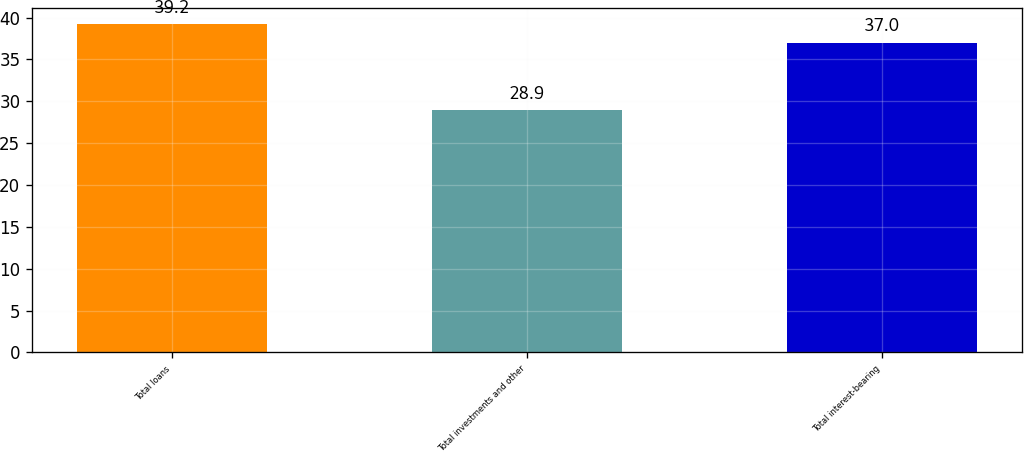Convert chart to OTSL. <chart><loc_0><loc_0><loc_500><loc_500><bar_chart><fcel>Total loans<fcel>Total investments and other<fcel>Total interest-bearing<nl><fcel>39.2<fcel>28.9<fcel>37<nl></chart> 